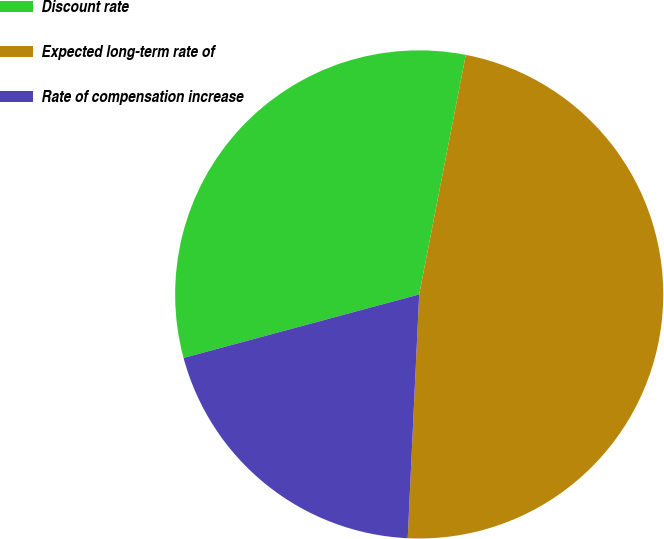Convert chart to OTSL. <chart><loc_0><loc_0><loc_500><loc_500><pie_chart><fcel>Discount rate<fcel>Expected long-term rate of<fcel>Rate of compensation increase<nl><fcel>32.25%<fcel>47.69%<fcel>20.06%<nl></chart> 